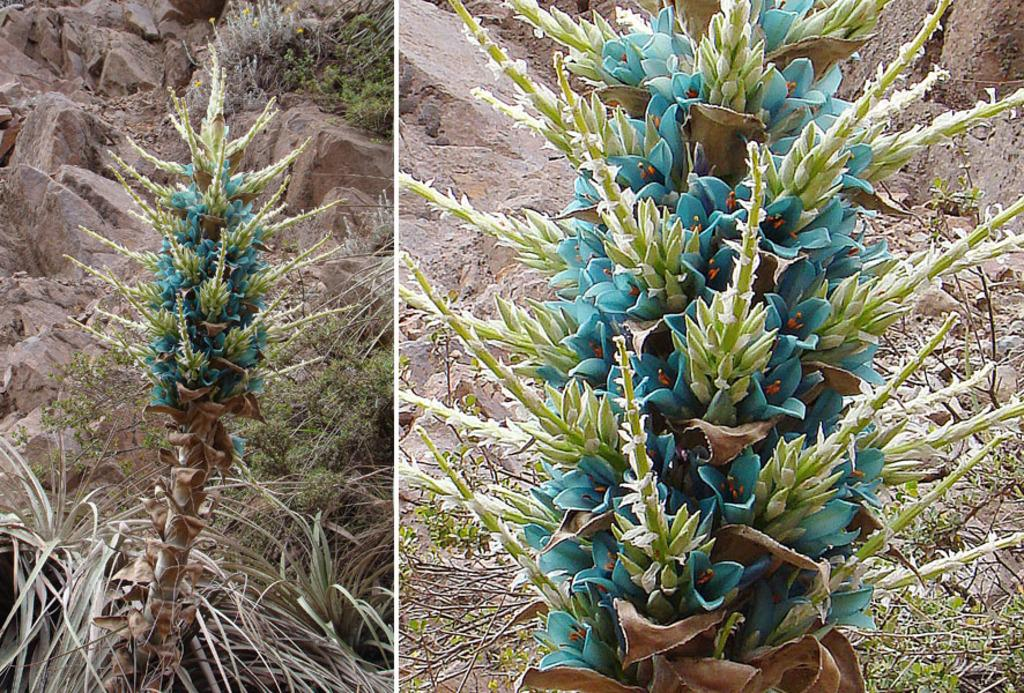What is the main subject of the collage in the image? The collage contains the same content, so the main subject is a plant in the center of the image. What can be seen in the background of the image? There are rocks in the background of the image. What type of vegetation is at the bottom of the image? There is grass at the bottom of the image. What type of house can be seen in the background of the image? There is no house present in the image; it features a plant in the center, rocks in the background, and grass at the bottom. Can you hear the voice of the plant in the image? Plants do not have voices, so it is not possible to hear the voice of the plant in the image. 